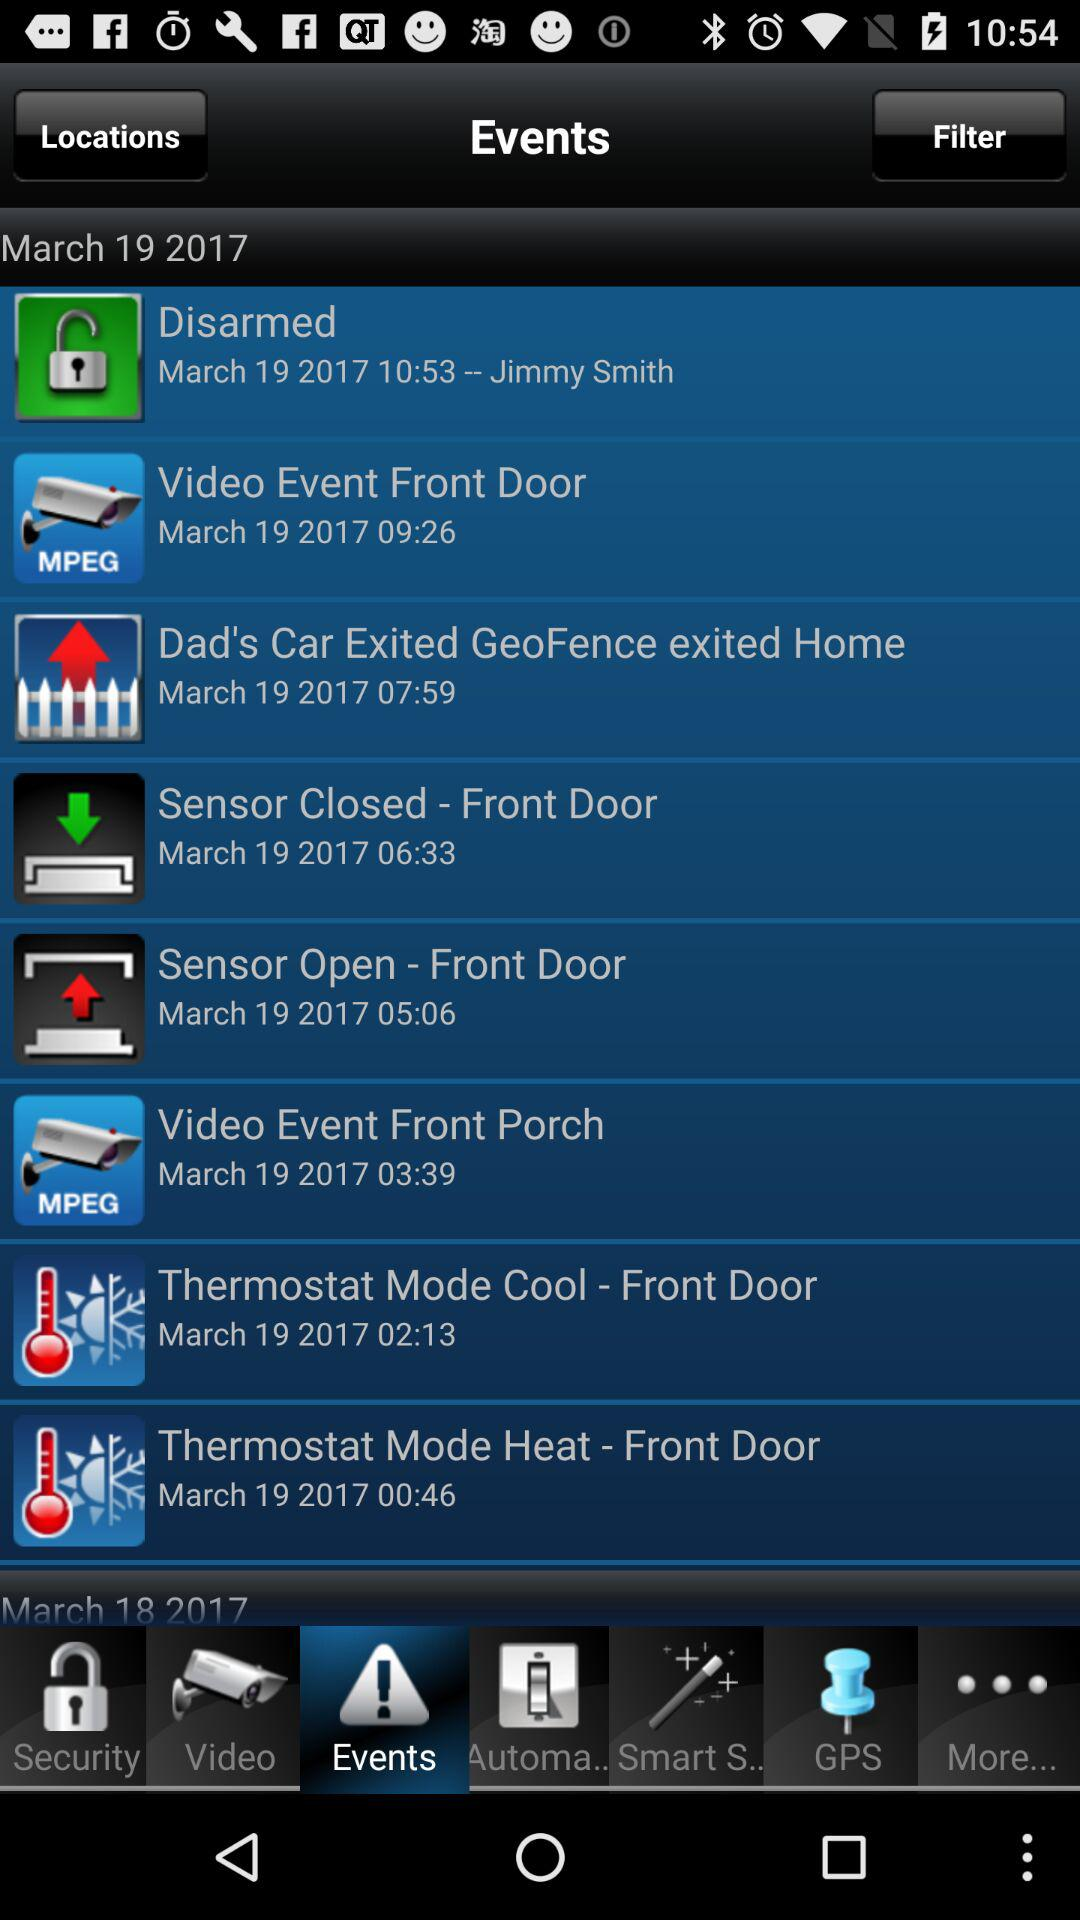What is the date of the "Disarmed" event? The date of the "Disarmed" event is March 19, 2017. 